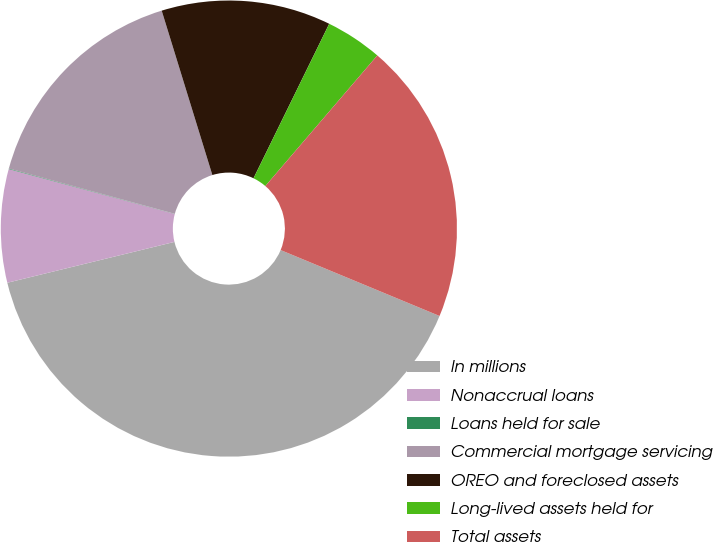Convert chart. <chart><loc_0><loc_0><loc_500><loc_500><pie_chart><fcel>In millions<fcel>Nonaccrual loans<fcel>Loans held for sale<fcel>Commercial mortgage servicing<fcel>OREO and foreclosed assets<fcel>Long-lived assets held for<fcel>Total assets<nl><fcel>39.93%<fcel>8.02%<fcel>0.04%<fcel>16.0%<fcel>12.01%<fcel>4.03%<fcel>19.98%<nl></chart> 